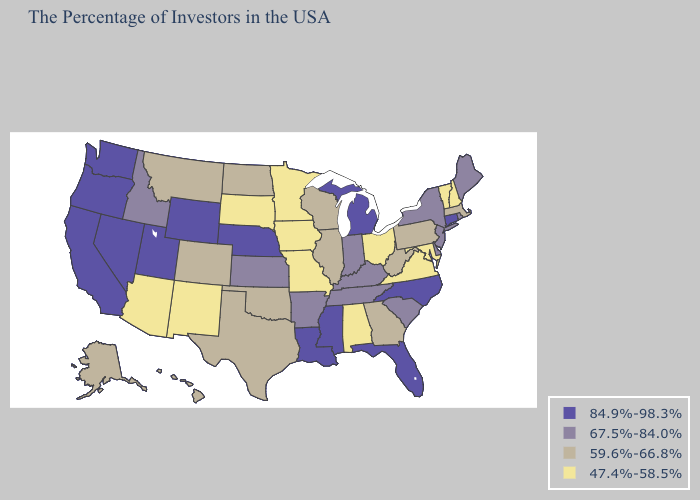What is the value of Florida?
Concise answer only. 84.9%-98.3%. Does Delaware have the same value as Alabama?
Give a very brief answer. No. Does Louisiana have the highest value in the South?
Keep it brief. Yes. Does Hawaii have the highest value in the West?
Answer briefly. No. Which states have the lowest value in the Northeast?
Answer briefly. New Hampshire, Vermont. What is the value of Idaho?
Write a very short answer. 67.5%-84.0%. What is the value of Massachusetts?
Keep it brief. 59.6%-66.8%. Name the states that have a value in the range 59.6%-66.8%?
Short answer required. Massachusetts, Pennsylvania, West Virginia, Georgia, Wisconsin, Illinois, Oklahoma, Texas, North Dakota, Colorado, Montana, Alaska, Hawaii. Does North Dakota have the lowest value in the USA?
Concise answer only. No. Does the map have missing data?
Concise answer only. No. Name the states that have a value in the range 59.6%-66.8%?
Write a very short answer. Massachusetts, Pennsylvania, West Virginia, Georgia, Wisconsin, Illinois, Oklahoma, Texas, North Dakota, Colorado, Montana, Alaska, Hawaii. Does Utah have the highest value in the West?
Keep it brief. Yes. Does Connecticut have the highest value in the Northeast?
Short answer required. Yes. What is the highest value in the USA?
Concise answer only. 84.9%-98.3%. What is the value of Colorado?
Short answer required. 59.6%-66.8%. 